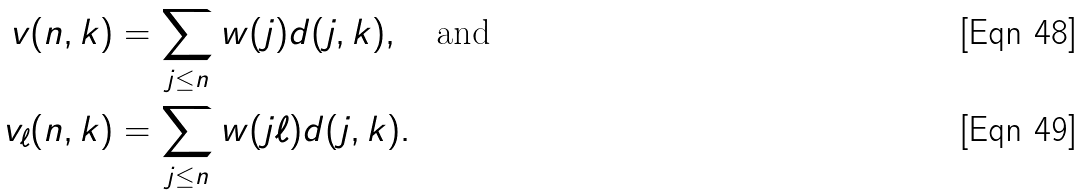<formula> <loc_0><loc_0><loc_500><loc_500>v ( n , k ) & = \sum _ { j \leq n } w ( j ) d ( j , k ) , \quad \text {and} \\ v _ { \ell } ( n , k ) & = \sum _ { j \leq n } w ( j \ell ) d ( j , k ) .</formula> 